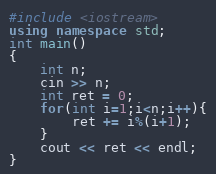Convert code to text. <code><loc_0><loc_0><loc_500><loc_500><_C++_>#include <iostream>
using namespace std;
int main()
{
    int n;
    cin >> n;
    int ret = 0;
    for(int i=1;i<n;i++){
        ret += i%(i+1);
    }
    cout << ret << endl;
}</code> 